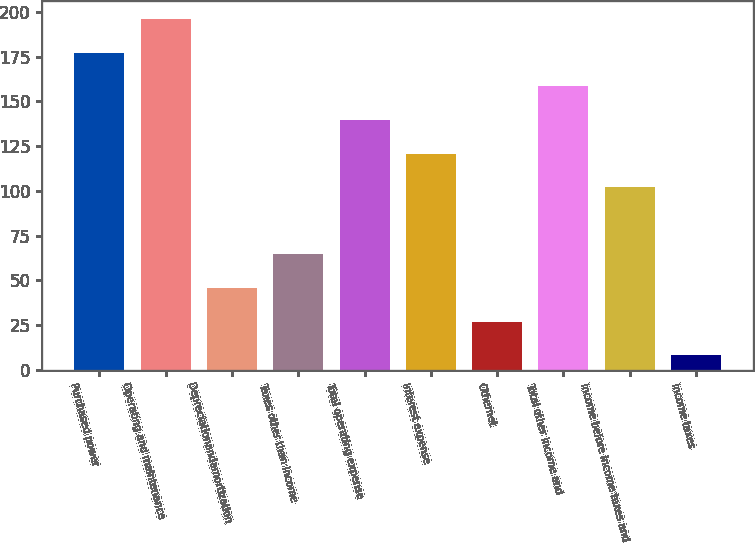<chart> <loc_0><loc_0><loc_500><loc_500><bar_chart><fcel>Purchased power<fcel>Operating and maintenance<fcel>Depreciationandamortization<fcel>Taxes other than income<fcel>Total operating expense<fcel>Interest expense<fcel>Othernet<fcel>Total other income and<fcel>Income before income taxes and<fcel>Income taxes<nl><fcel>177.2<fcel>196<fcel>45.6<fcel>64.4<fcel>139.6<fcel>120.8<fcel>26.8<fcel>158.4<fcel>102<fcel>8<nl></chart> 